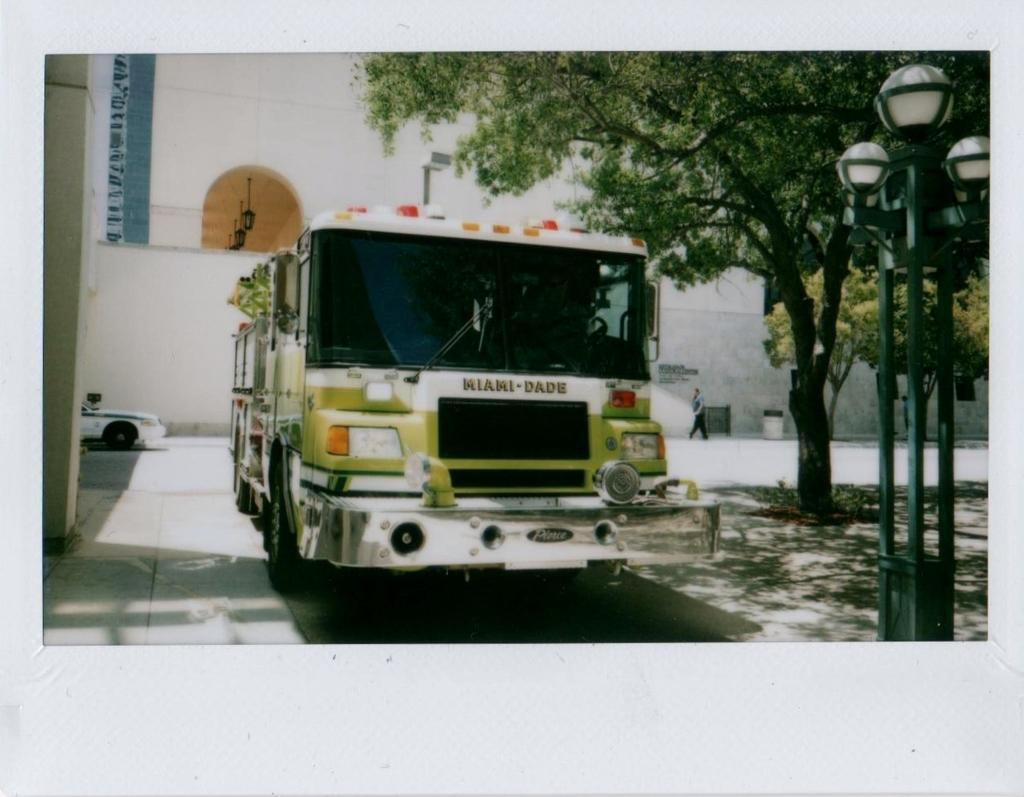What is the main subject in the center of the image? There is a fire engine in the center of the image. What can be seen on the right side of the image? There are street lights, trees, and a road on the right side of the image. What is on the left side of the image? There is a car and a wall on the left side of the image. What is the weather like in the image? It is sunny in the image. What type of plastic toy can be seen in the image? There is no plastic toy present in the image. What town is depicted in the image? The image does not depict a specific town; it shows a fire engine, street lights, trees, a road, a car, and a wall. 